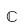Convert formula to latex. <formula><loc_0><loc_0><loc_500><loc_500>\mathbb { C }</formula> 